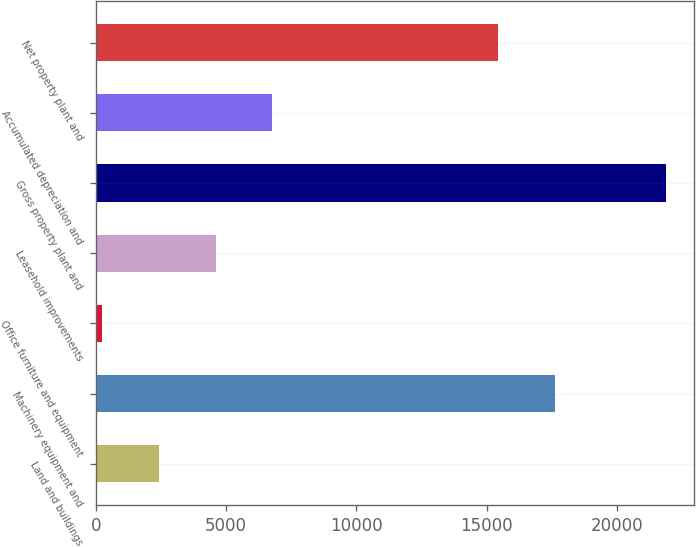Convert chart to OTSL. <chart><loc_0><loc_0><loc_500><loc_500><bar_chart><fcel>Land and buildings<fcel>Machinery equipment and<fcel>Office furniture and equipment<fcel>Leasehold improvements<fcel>Gross property plant and<fcel>Accumulated depreciation and<fcel>Net property plant and<nl><fcel>2439<fcel>17616.6<fcel>241<fcel>4603.6<fcel>21887<fcel>6768.2<fcel>15452<nl></chart> 